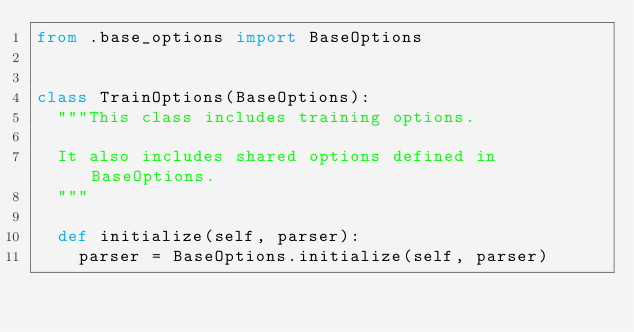<code> <loc_0><loc_0><loc_500><loc_500><_Python_>from .base_options import BaseOptions


class TrainOptions(BaseOptions):
	"""This class includes training options.

	It also includes shared options defined in BaseOptions.
	"""

	def initialize(self, parser):
		parser = BaseOptions.initialize(self, parser)</code> 